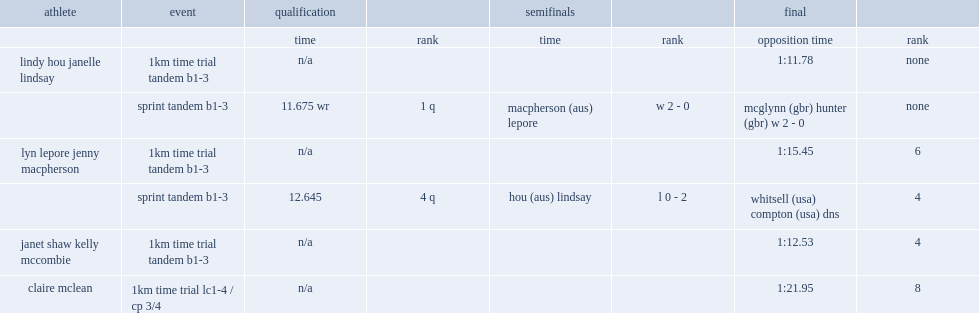What was the world record made by lindy hou and janelle lindsay? 11.675 wr. 